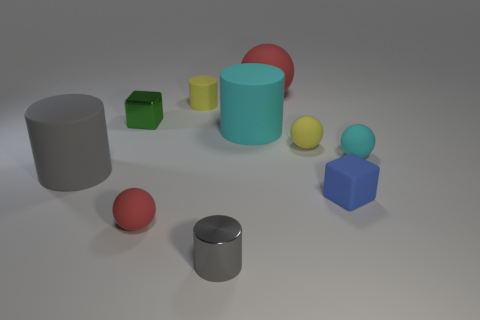How big is the cyan cylinder?
Ensure brevity in your answer.  Large. The gray thing on the right side of the big gray cylinder has what shape?
Offer a terse response. Cylinder. Is the large cyan rubber thing the same shape as the big red object?
Your answer should be very brief. No. Is the number of blue blocks that are right of the tiny blue rubber block the same as the number of tiny cylinders?
Ensure brevity in your answer.  No. There is a blue object; what shape is it?
Provide a succinct answer. Cube. Are there any other things of the same color as the matte block?
Provide a short and direct response. No. There is a cylinder on the right side of the gray shiny object; does it have the same size as the red thing that is in front of the matte cube?
Provide a short and direct response. No. There is a metal object that is on the right side of the small block that is to the left of the small rubber cylinder; what is its shape?
Keep it short and to the point. Cylinder. Is the size of the metallic cylinder the same as the gray object behind the tiny gray cylinder?
Ensure brevity in your answer.  No. There is a cyan matte thing to the right of the large matte cylinder that is right of the red matte sphere left of the large cyan rubber object; what is its size?
Ensure brevity in your answer.  Small. 